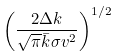<formula> <loc_0><loc_0><loc_500><loc_500>\left ( { \frac { 2 \Delta k } { \sqrt { \pi } \bar { k } \sigma v ^ { 2 } } } \right ) ^ { 1 / 2 }</formula> 